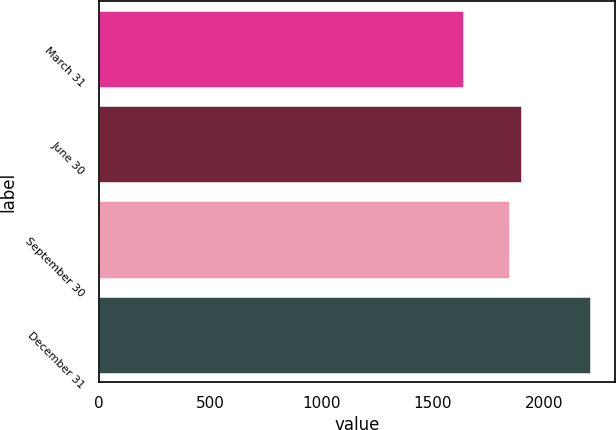Convert chart to OTSL. <chart><loc_0><loc_0><loc_500><loc_500><bar_chart><fcel>March 31<fcel>June 30<fcel>September 30<fcel>December 31<nl><fcel>1637.5<fcel>1898.06<fcel>1841.1<fcel>2207.1<nl></chart> 